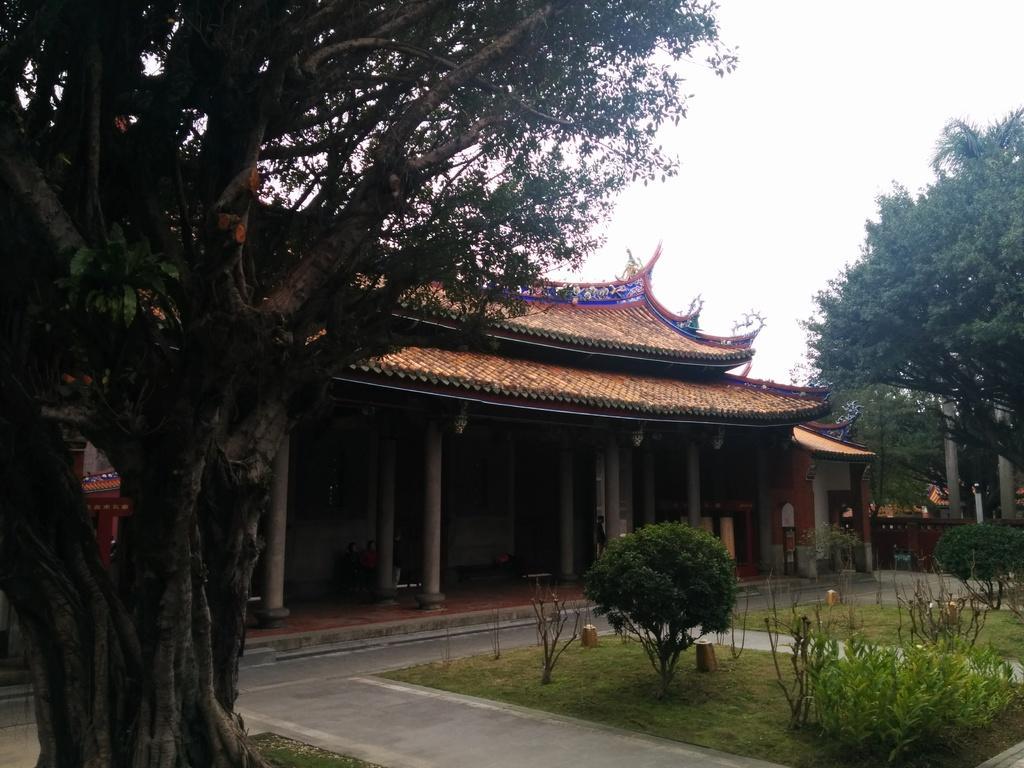Could you give a brief overview of what you see in this image? There is a tree in the foreground and a house structure and pillars in the center. There are plants, trees and poles on the right side and sky in the background area. 